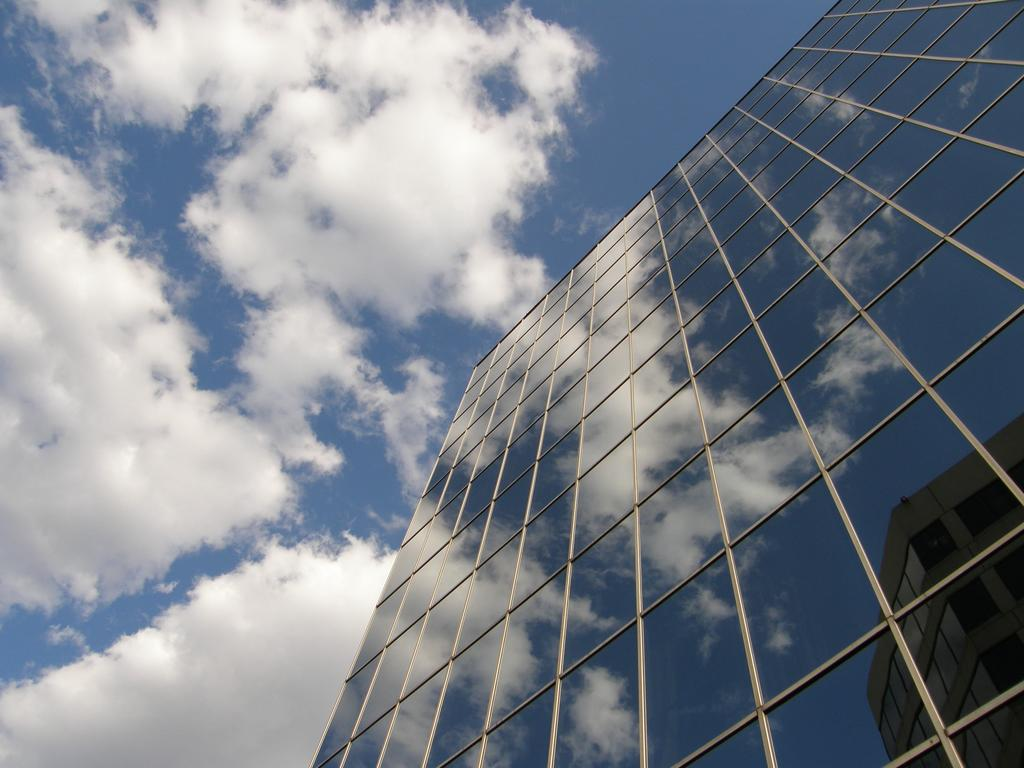What type of building is shown in the image? There is a tall building made of glass in the image. From where is the view of the building taken? The view is from the bottom of the building. What color is the sky in the image? The sky is blue in the image. Can you see any wires connecting the building to the ground in the image? There is no mention of wires connecting the building to the ground in the image. Are there any bears visible in the image? There is no mention of bears in the image. 